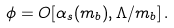<formula> <loc_0><loc_0><loc_500><loc_500>\phi = O [ \alpha _ { s } ( m _ { b } ) , \Lambda / m _ { b } ] \, .</formula> 